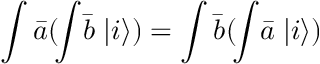<formula> <loc_0><loc_0><loc_500><loc_500>\int { \bar { a } } ( \, \int \, { \bar { b } } \, | i \rangle ) = \int { \bar { b } } ( \, \int \, { \bar { a } } \, | i \rangle )</formula> 